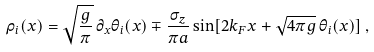<formula> <loc_0><loc_0><loc_500><loc_500>\rho _ { i } ( x ) = \sqrt { \frac { g } { \pi } } \, \partial _ { x } \theta _ { i } ( x ) \mp \frac { \sigma _ { z } } { \pi a } \sin [ 2 k _ { F } x + \sqrt { 4 \pi g } \, \theta _ { i } ( x ) ] \, ,</formula> 